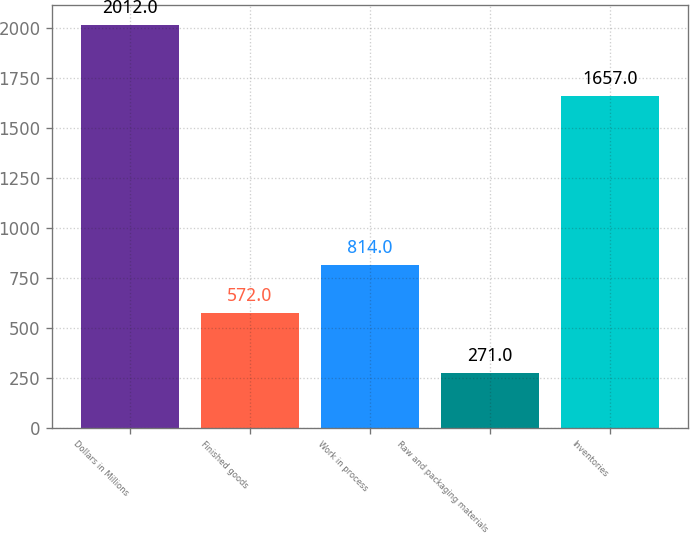<chart> <loc_0><loc_0><loc_500><loc_500><bar_chart><fcel>Dollars in Millions<fcel>Finished goods<fcel>Work in process<fcel>Raw and packaging materials<fcel>Inventories<nl><fcel>2012<fcel>572<fcel>814<fcel>271<fcel>1657<nl></chart> 